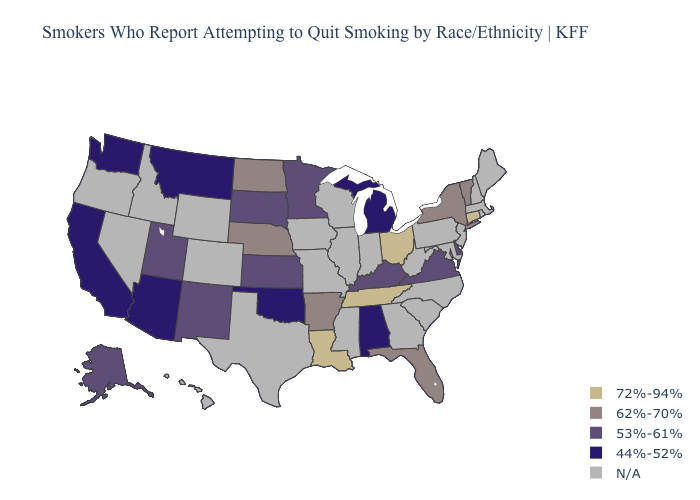What is the value of Mississippi?
Quick response, please. N/A. What is the value of Vermont?
Write a very short answer. 62%-70%. What is the highest value in states that border Florida?
Be succinct. 44%-52%. What is the value of Idaho?
Be succinct. N/A. Which states have the lowest value in the USA?
Concise answer only. Alabama, Arizona, California, Michigan, Montana, Oklahoma, Washington. Name the states that have a value in the range 62%-70%?
Give a very brief answer. Arkansas, Florida, Nebraska, New York, North Dakota, Vermont. Does Delaware have the lowest value in the South?
Answer briefly. No. Is the legend a continuous bar?
Answer briefly. No. Name the states that have a value in the range 62%-70%?
Answer briefly. Arkansas, Florida, Nebraska, New York, North Dakota, Vermont. Does Tennessee have the lowest value in the USA?
Quick response, please. No. What is the value of West Virginia?
Give a very brief answer. N/A. Name the states that have a value in the range 72%-94%?
Concise answer only. Connecticut, Louisiana, Ohio, Tennessee. Name the states that have a value in the range N/A?
Quick response, please. Colorado, Georgia, Hawaii, Idaho, Illinois, Indiana, Iowa, Maine, Maryland, Massachusetts, Mississippi, Missouri, Nevada, New Hampshire, New Jersey, North Carolina, Oregon, Pennsylvania, Rhode Island, South Carolina, Texas, West Virginia, Wisconsin, Wyoming. Which states hav the highest value in the Northeast?
Keep it brief. Connecticut. 